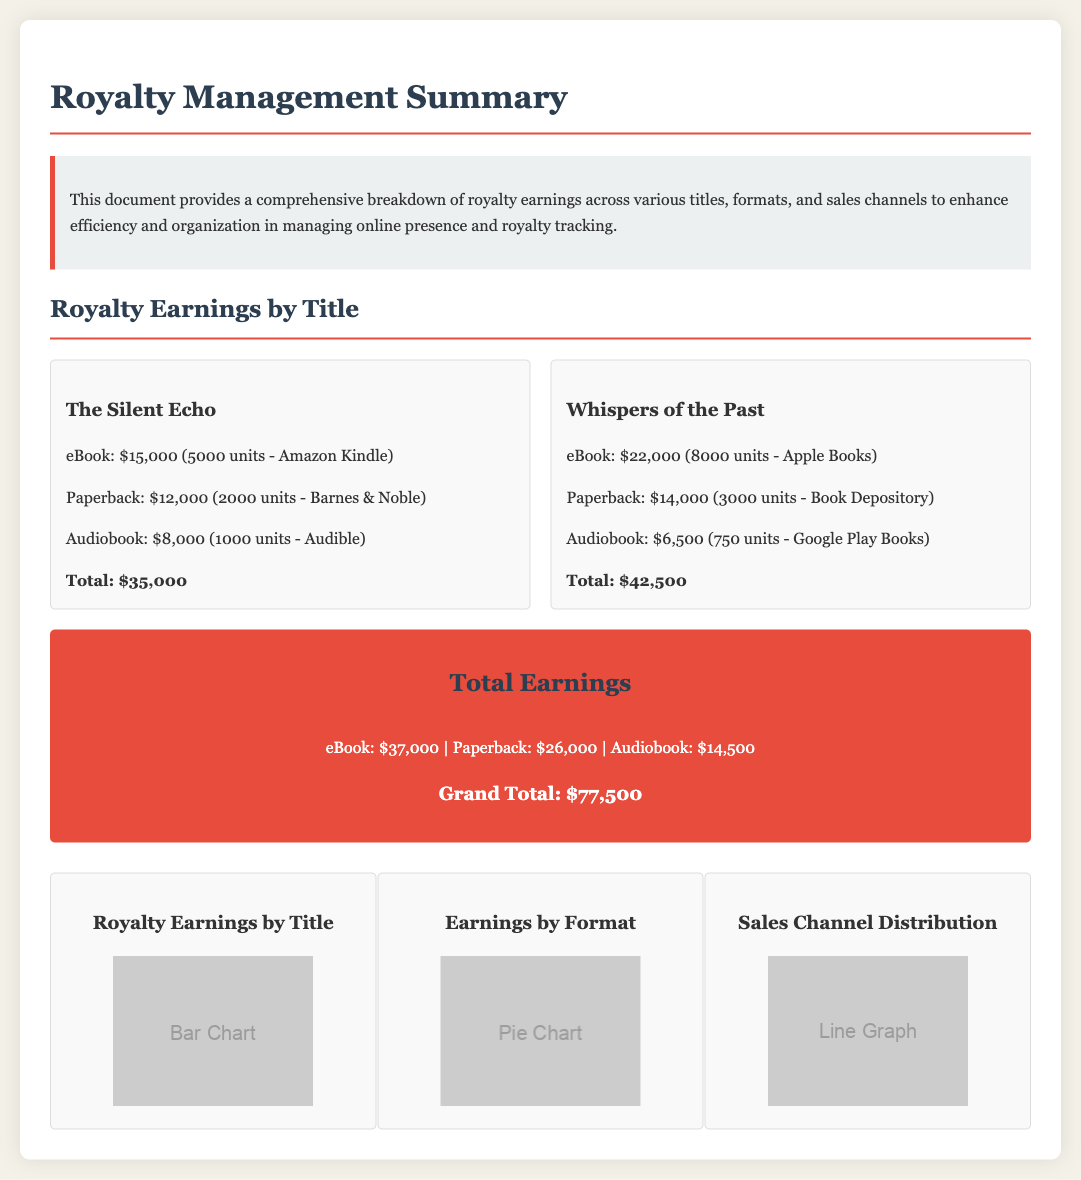What are the total earnings for eBooks? The total earnings for eBooks are listed as $37,000 in the document.
Answer: $37,000 How many units of "The Silent Echo" were sold in eBook format? The document states that 5,000 units of "The Silent Echo" were sold in eBook format.
Answer: 5000 units Which title earned the highest total? The title that earned the highest total is "Whispers of the Past," with $42,500 in earnings.
Answer: Whispers of the Past What is the total revenue for audiobooks? The total revenue for audiobooks is the cumulative amount from all titles listed, which equals $14,500.
Answer: $14,500 How many formats are mentioned in the earnings summary? The document mentions three formats: eBook, paperback, and audiobook.
Answer: Three formats What is the total earning from "The Silent Echo"? The total earnings from "The Silent Echo" add up to $35,000, as detailed in the document.
Answer: $35,000 Which sales channel generated the most revenue for "Whispers of the Past"? The sales channel that generated the most revenue for "Whispers of the Past" is Apple Books.
Answer: Apple Books What is the grand total of all earnings? The grand total of all earnings is stated as $77,500 in the document.
Answer: $77,500 What type of charts are included in the summary? The document includes a bar chart, a pie chart, and a line graph.
Answer: Bar chart, pie chart, line graph 